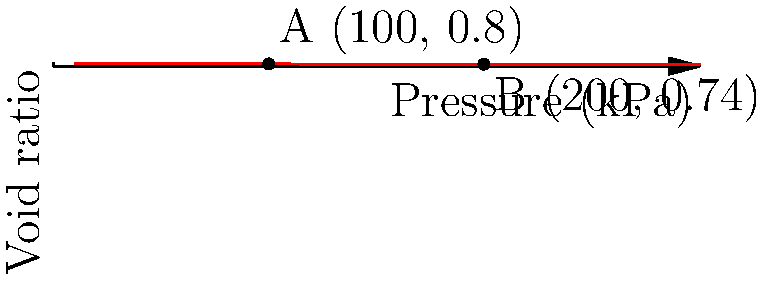A building foundation is expected to increase the effective stress in a clay layer from 100 kPa to 200 kPa. Given the compression curve shown in the figure, estimate the settlement of a 5m thick clay layer. Assume the clay is normally consolidated. To estimate the settlement, we'll follow these steps:

1) First, we need to calculate the change in void ratio ($\Delta e$) from the compression curve:
   At point A: $e_1 = 0.8$ (at 100 kPa)
   At point B: $e_2 = 0.74$ (at 200 kPa)
   $\Delta e = e_1 - e_2 = 0.8 - 0.74 = 0.06$

2) The settlement (S) can be calculated using the formula:
   $S = H \frac{\Delta e}{1 + e_0}$
   Where H is the thickness of the clay layer and $e_0$ is the initial void ratio.

3) We're given H = 5m, and we can use $e_1$ as $e_0$ since the clay is normally consolidated.

4) Plugging in the values:
   $S = 5m \frac{0.06}{1 + 0.8} = \frac{0.3}{1.8} = 0.167m$

5) Convert to cm:
   $S = 0.167m * 100 \frac{cm}{m} = 16.7cm$

Therefore, the estimated settlement of the clay layer is approximately 16.7 cm.
Answer: 16.7 cm 